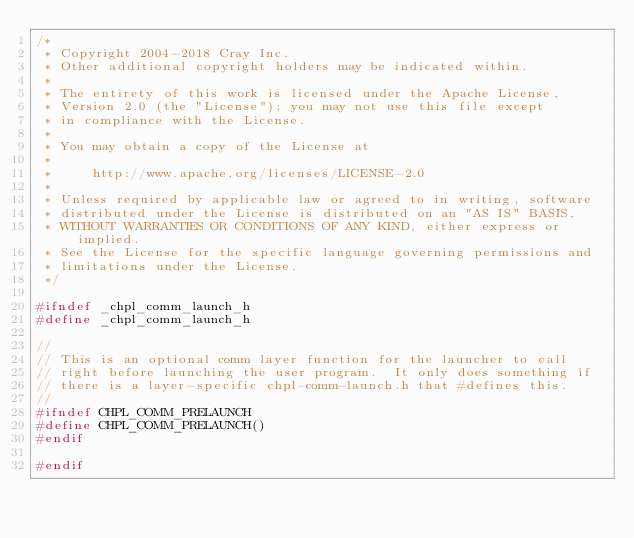Convert code to text. <code><loc_0><loc_0><loc_500><loc_500><_C_>/*
 * Copyright 2004-2018 Cray Inc.
 * Other additional copyright holders may be indicated within.
 * 
 * The entirety of this work is licensed under the Apache License,
 * Version 2.0 (the "License"); you may not use this file except
 * in compliance with the License.
 * 
 * You may obtain a copy of the License at
 * 
 *     http://www.apache.org/licenses/LICENSE-2.0
 * 
 * Unless required by applicable law or agreed to in writing, software
 * distributed under the License is distributed on an "AS IS" BASIS,
 * WITHOUT WARRANTIES OR CONDITIONS OF ANY KIND, either express or implied.
 * See the License for the specific language governing permissions and
 * limitations under the License.
 */

#ifndef _chpl_comm_launch_h
#define _chpl_comm_launch_h

//
// This is an optional comm layer function for the launcher to call
// right before launching the user program.  It only does something if
// there is a layer-specific chpl-comm-launch.h that #defines this.
//
#ifndef CHPL_COMM_PRELAUNCH
#define CHPL_COMM_PRELAUNCH()
#endif

#endif
</code> 